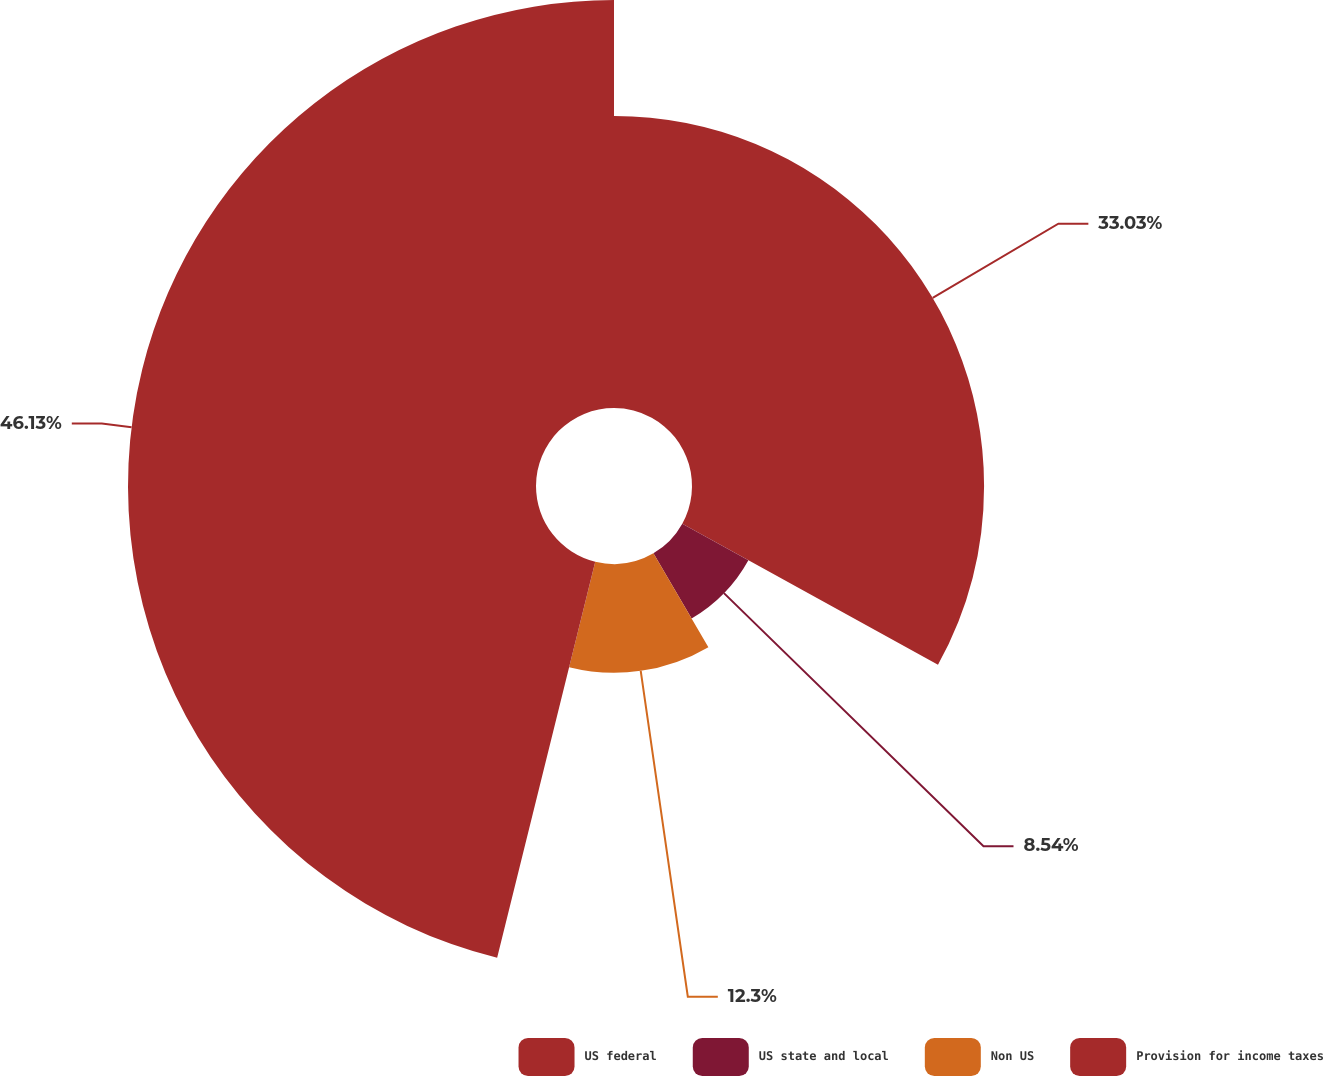<chart> <loc_0><loc_0><loc_500><loc_500><pie_chart><fcel>US federal<fcel>US state and local<fcel>Non US<fcel>Provision for income taxes<nl><fcel>33.03%<fcel>8.54%<fcel>12.3%<fcel>46.14%<nl></chart> 